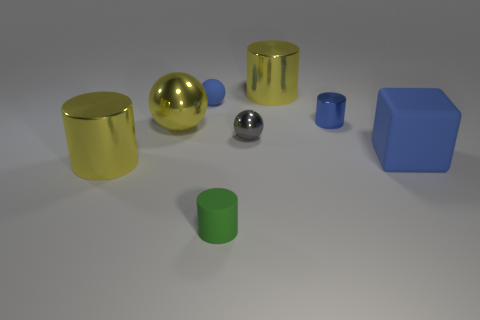Subtract all big balls. How many balls are left? 2 Subtract all cyan balls. How many yellow cylinders are left? 2 Add 2 large yellow matte things. How many objects exist? 10 Subtract all green cylinders. How many cylinders are left? 3 Subtract all cyan cylinders. Subtract all gray balls. How many cylinders are left? 4 Subtract 0 brown cylinders. How many objects are left? 8 Subtract all blocks. How many objects are left? 7 Subtract all cylinders. Subtract all big matte cubes. How many objects are left? 3 Add 4 small blue shiny cylinders. How many small blue shiny cylinders are left? 5 Add 5 large gray cylinders. How many large gray cylinders exist? 5 